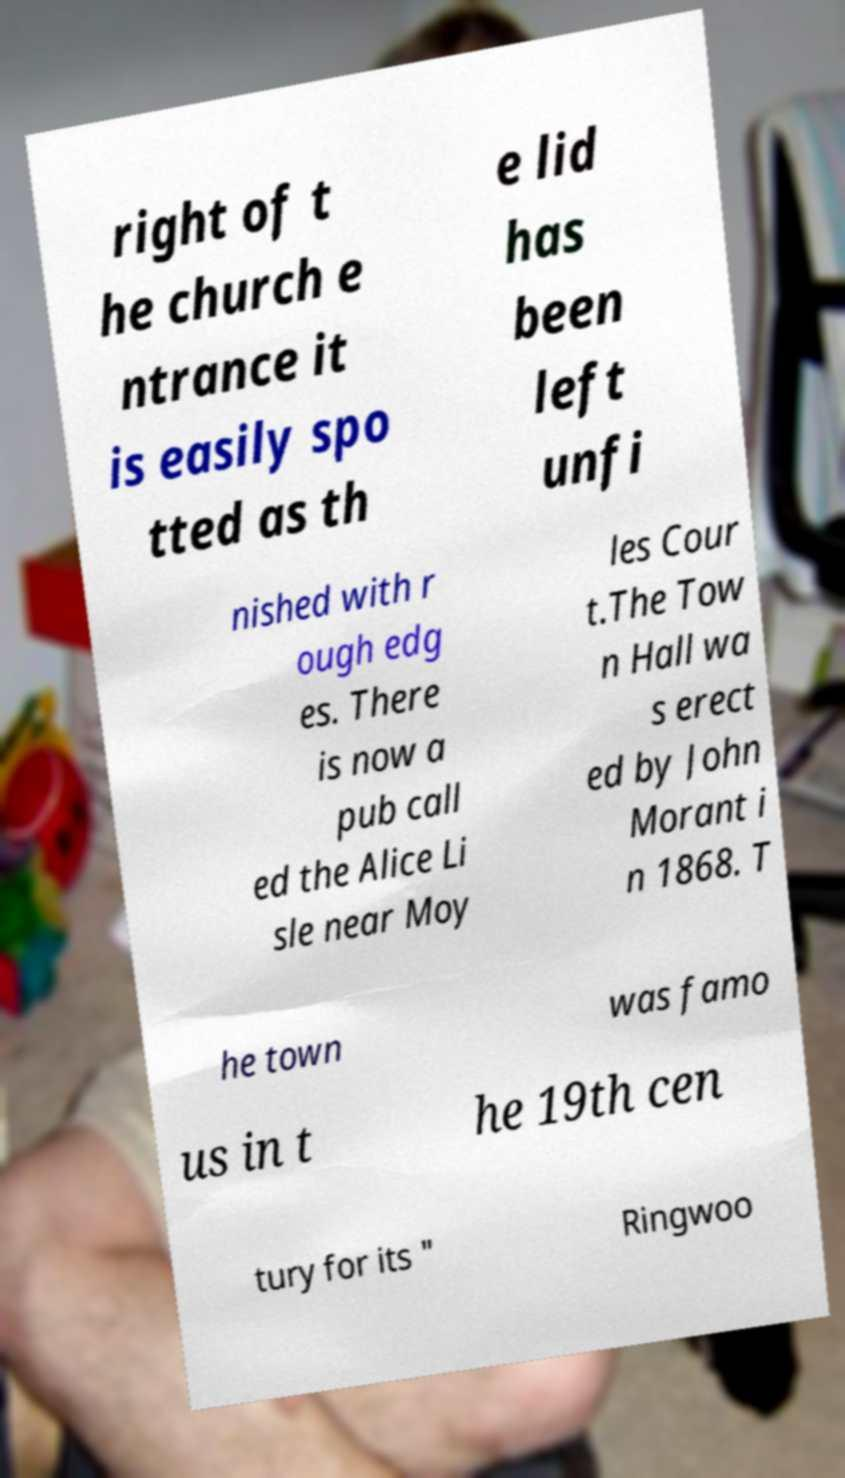Can you read and provide the text displayed in the image?This photo seems to have some interesting text. Can you extract and type it out for me? right of t he church e ntrance it is easily spo tted as th e lid has been left unfi nished with r ough edg es. There is now a pub call ed the Alice Li sle near Moy les Cour t.The Tow n Hall wa s erect ed by John Morant i n 1868. T he town was famo us in t he 19th cen tury for its " Ringwoo 